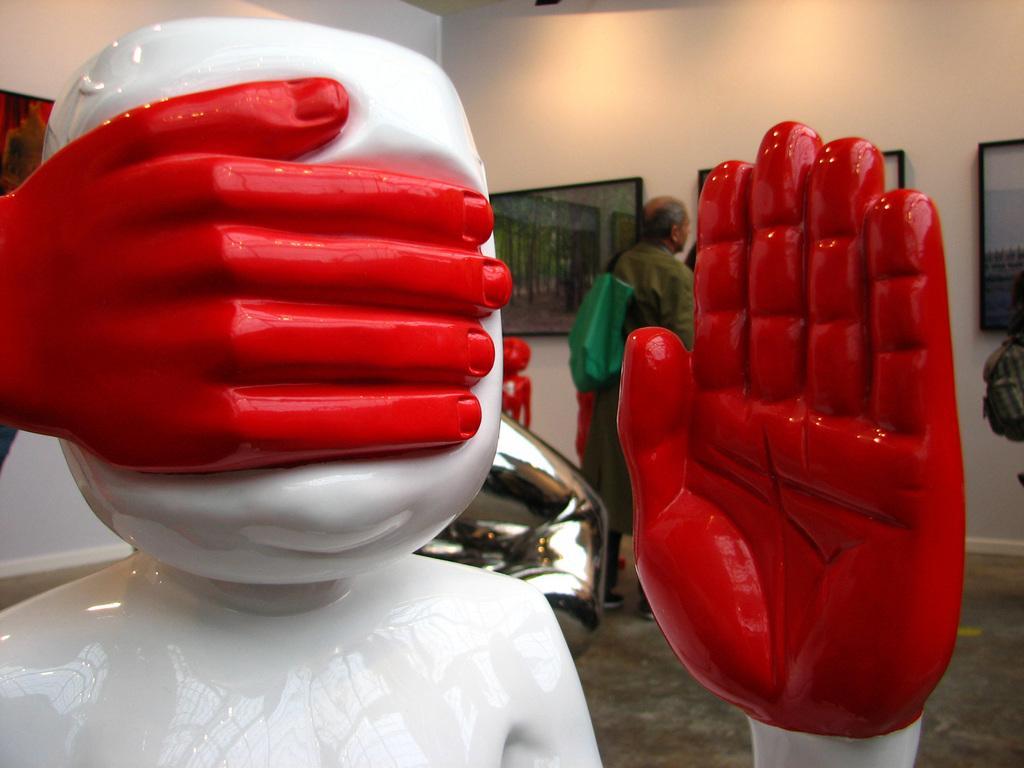Can you describe this image briefly? In the front of the image there is a statue. In the background of the image there are pictures, walls, person and objects. Pictures are on the wall. 